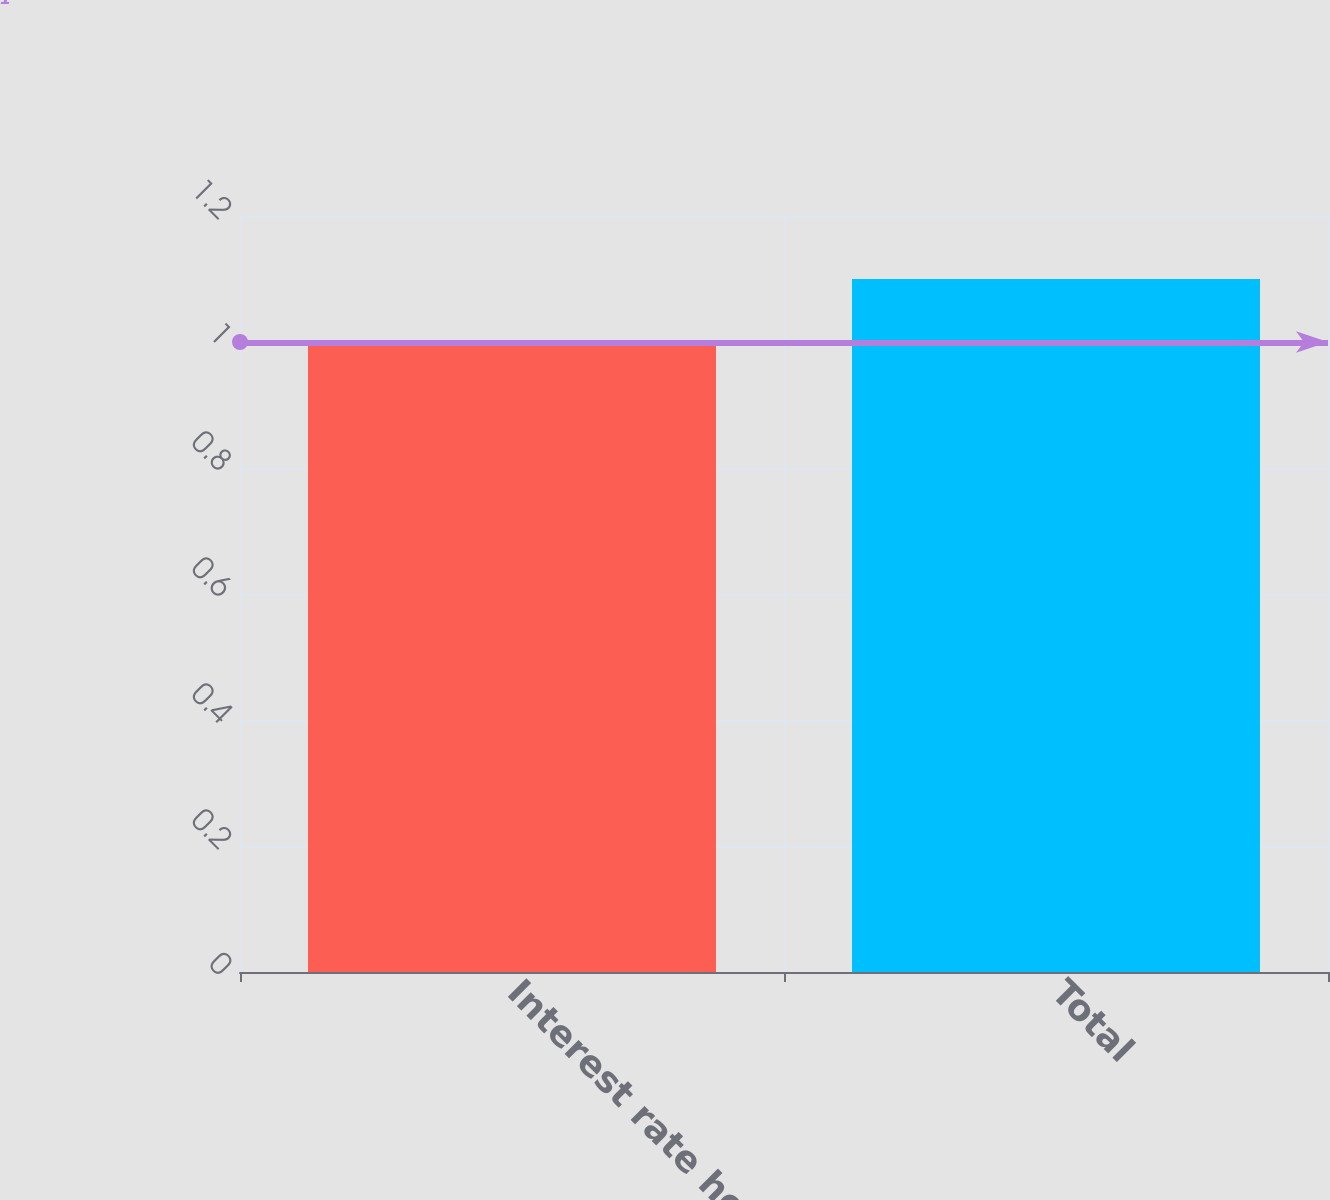<chart> <loc_0><loc_0><loc_500><loc_500><bar_chart><fcel>Interest rate hedges<fcel>Total<nl><fcel>1<fcel>1.1<nl></chart> 